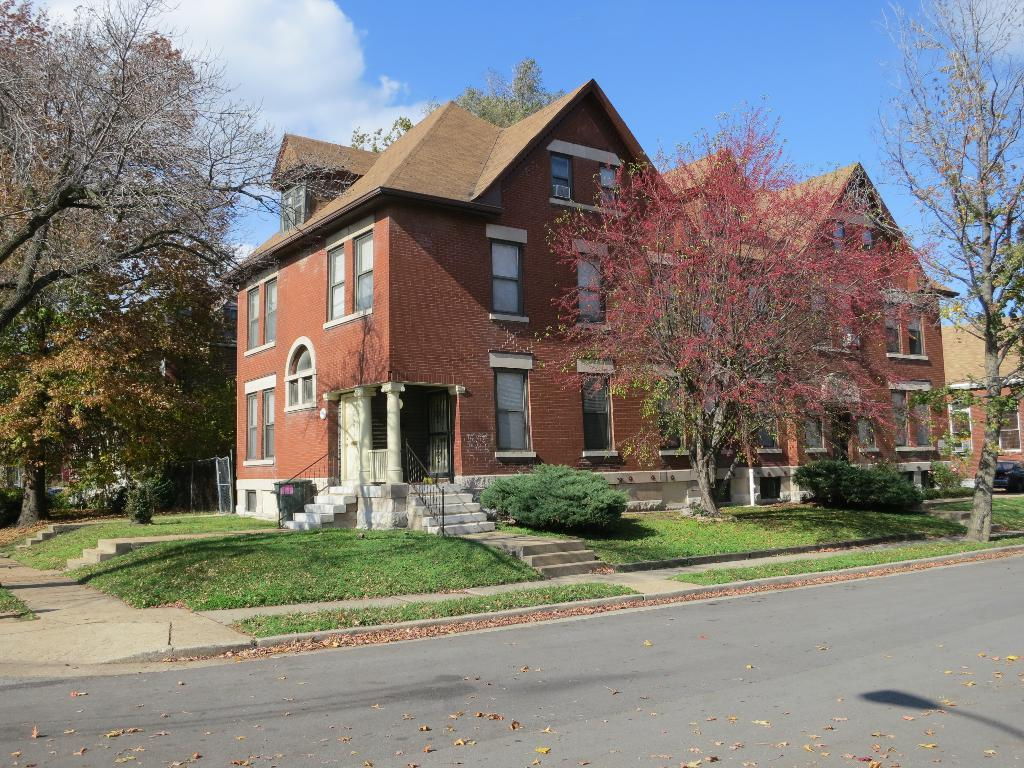What type of pathway can be seen in the image? There is a road in the image. What natural elements are present in the image? Dry leaves, grass, shrubs, trees, and clouds are present in the image. Are there any architectural features in the image? Yes, there are stairs and a house in the image. What is visible in the background of the image? The sky is visible in the background of the image. Where is the cave located in the image? There is no cave present in the image. What type of quilt is draped over the tree in the image? There is no quilt present in the image. 